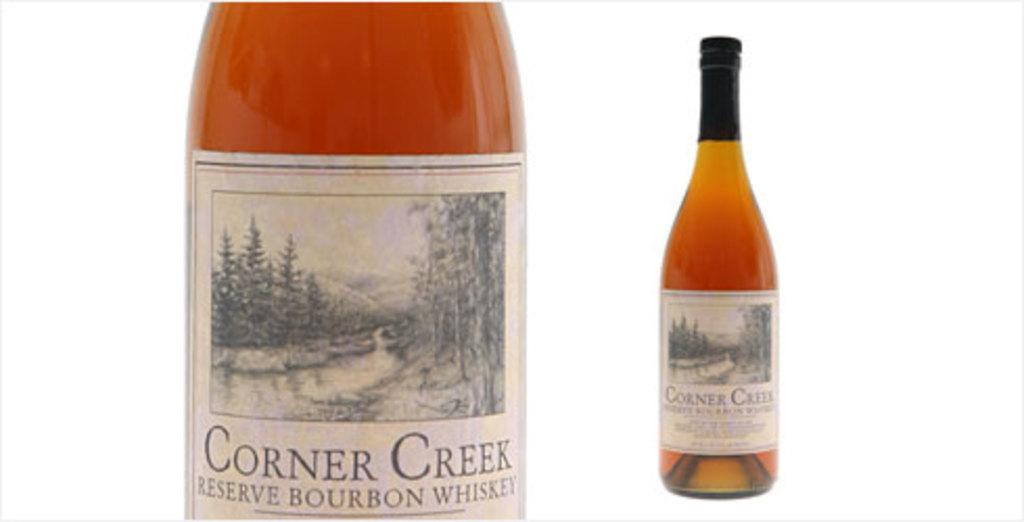<image>
Write a terse but informative summary of the picture. the name corner creek is written on a bottle 